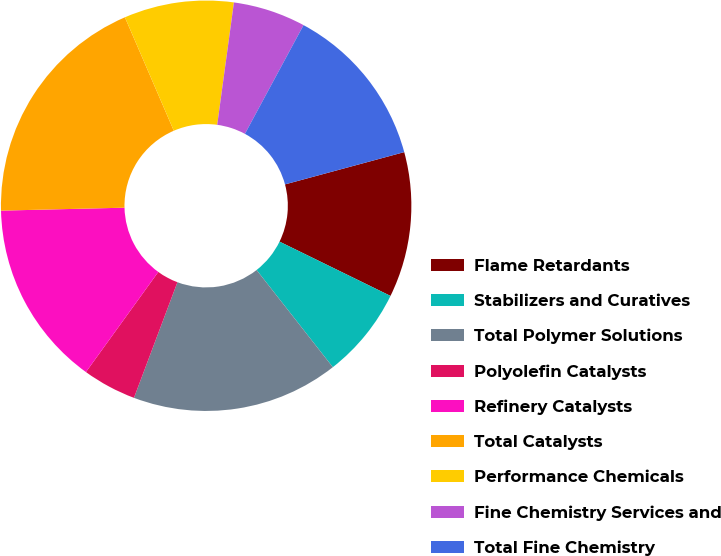Convert chart. <chart><loc_0><loc_0><loc_500><loc_500><pie_chart><fcel>Flame Retardants<fcel>Stabilizers and Curatives<fcel>Total Polymer Solutions<fcel>Polyolefin Catalysts<fcel>Refinery Catalysts<fcel>Total Catalysts<fcel>Performance Chemicals<fcel>Fine Chemistry Services and<fcel>Total Fine Chemistry<nl><fcel>11.45%<fcel>7.17%<fcel>16.31%<fcel>4.24%<fcel>14.66%<fcel>18.9%<fcel>8.64%<fcel>5.71%<fcel>12.92%<nl></chart> 